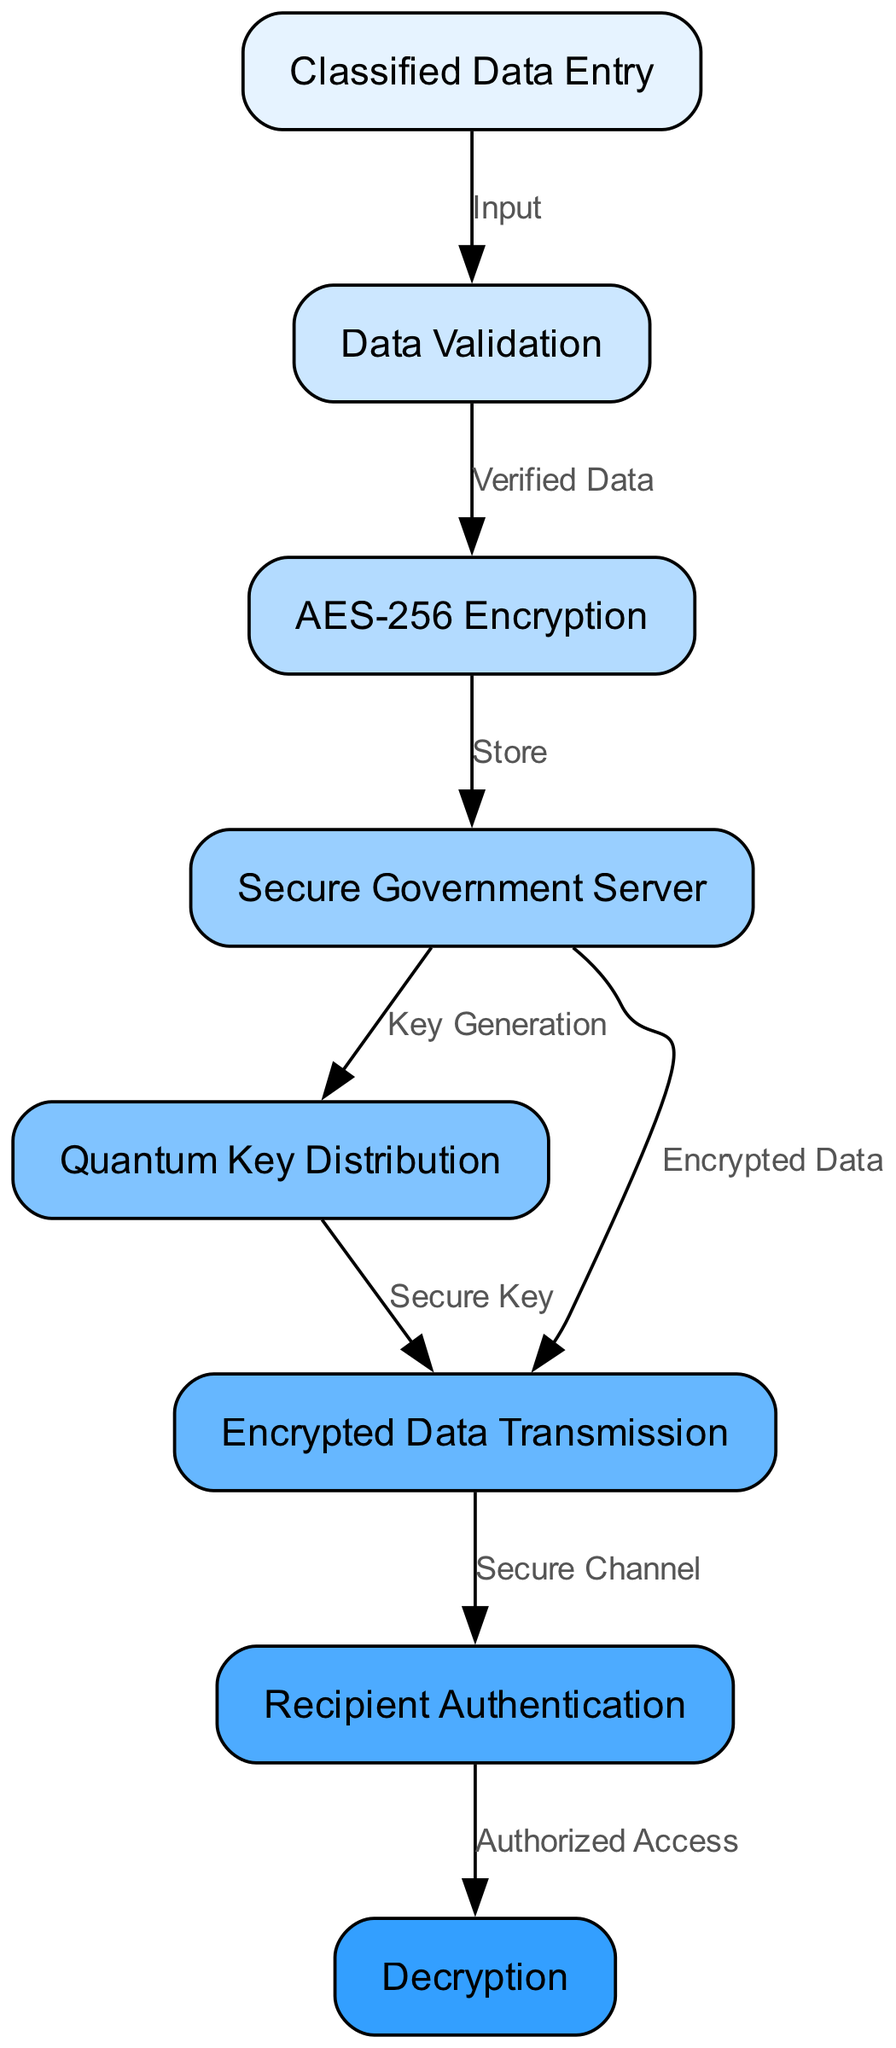What is the first step in the workflow? The diagram indicates that the first step is "Classified Data Entry," which is represented as node 1. This is where the classified data is initially input into the system.
Answer: Classified Data Entry How many nodes are present in the diagram? By counting the nodes listed in the data, there are 8 distinct nodes outlined, each representing a different process or component of the workflow.
Answer: 8 What is the output of the "Data Validation" step? The output from the "Data Validation" step (node 2) leads to node 3, which is "AES-256 Encryption," and this transition is labeled "Verified Data," indicating that only validated data will continue to be processed.
Answer: Verified Data Which node is responsible for generating the secure key? According to the diagram, the node labeled "Quantum Key Distribution" (node 5) is responsible for generating the secure key that is needed for the encryption and transmission of data.
Answer: Quantum Key Distribution What happens to the data after "AES-256 Encryption"? After the "AES-256 Encryption" step (node 3), the encrypted data is sent to the "Secure Government Server" (node 4) for storage, as indicated by the edge labeled "Store." This shows that encryption precedes data storage.
Answer: Secure Government Server What is required before proceeding to "Decryption"? Before moving to the "Decryption" step (node 8), "Recipient Authentication" (node 7) must take place. This means that the recipient must be properly authenticated to ensure that decryption can occur securely and only by authorized individuals.
Answer: Recipient Authentication How is the data transmitted securely? Data is transmitted securely through the "Encrypted Data Transmission" step (node 6) after being stored on the "Secure Government Server" (node 4). The diagram shows that both nodes use the secure channel indicated by the edge leading to "Recipient Authentication."
Answer: Encrypted Data Transmission What is the relationship between "Secure Government Server" and "Encrypted Data Transmission"? The relationship indicates that the "Secure Government Server" (node 4) provides both the "Encrypted Data" and the "Quantum Key Distribution" as inputs to the "Encrypted Data Transmission" (node 6), signifying a direct flow of secure information.
Answer: Encrypted Data and Secure Key 